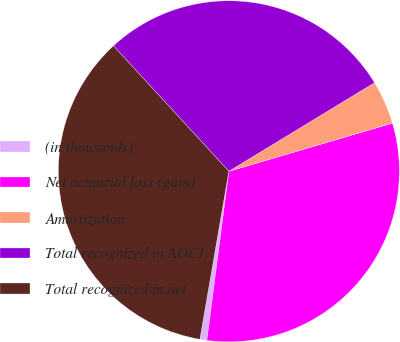Convert chart. <chart><loc_0><loc_0><loc_500><loc_500><pie_chart><fcel>(in thousands)<fcel>Net actuarial loss (gain)<fcel>Amortization<fcel>Total recognized in AOCI<fcel>Total recognized in net<nl><fcel>0.66%<fcel>31.62%<fcel>4.14%<fcel>28.14%<fcel>35.45%<nl></chart> 